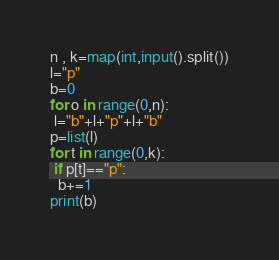Convert code to text. <code><loc_0><loc_0><loc_500><loc_500><_Python_>n , k=map(int,input().split())
l="p"
b=0
for o in range(0,n):
 l="b"+l+"p"+l+"b"
p=list(l)
for t in range(0,k):
 if p[t]=="p":
  b+=1
print(b)</code> 